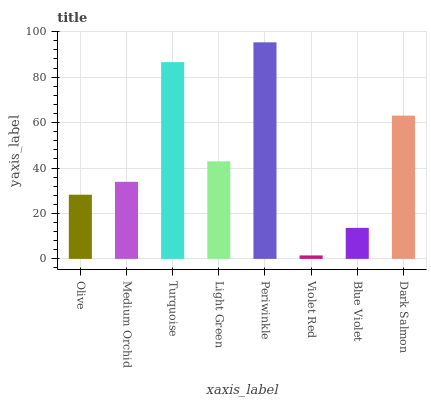Is Violet Red the minimum?
Answer yes or no. Yes. Is Periwinkle the maximum?
Answer yes or no. Yes. Is Medium Orchid the minimum?
Answer yes or no. No. Is Medium Orchid the maximum?
Answer yes or no. No. Is Medium Orchid greater than Olive?
Answer yes or no. Yes. Is Olive less than Medium Orchid?
Answer yes or no. Yes. Is Olive greater than Medium Orchid?
Answer yes or no. No. Is Medium Orchid less than Olive?
Answer yes or no. No. Is Light Green the high median?
Answer yes or no. Yes. Is Medium Orchid the low median?
Answer yes or no. Yes. Is Dark Salmon the high median?
Answer yes or no. No. Is Violet Red the low median?
Answer yes or no. No. 